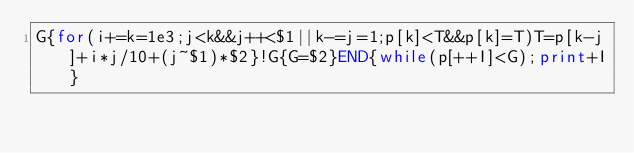Convert code to text. <code><loc_0><loc_0><loc_500><loc_500><_Awk_>G{for(i+=k=1e3;j<k&&j++<$1||k-=j=1;p[k]<T&&p[k]=T)T=p[k-j]+i*j/10+(j~$1)*$2}!G{G=$2}END{while(p[++I]<G);print+I}</code> 